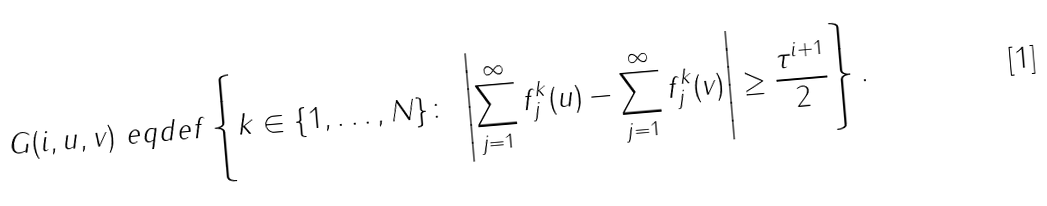<formula> <loc_0><loc_0><loc_500><loc_500>G ( i , u , v ) \ e q d e f \left \{ k \in \{ 1 , \dots , N \} \colon \ \left | \sum _ { j = 1 } ^ { \infty } f _ { j } ^ { k } ( u ) - \sum _ { j = 1 } ^ { \infty } f _ { j } ^ { k } ( v ) \right | \geq \frac { \tau ^ { i + 1 } } { 2 } \right \} .</formula> 